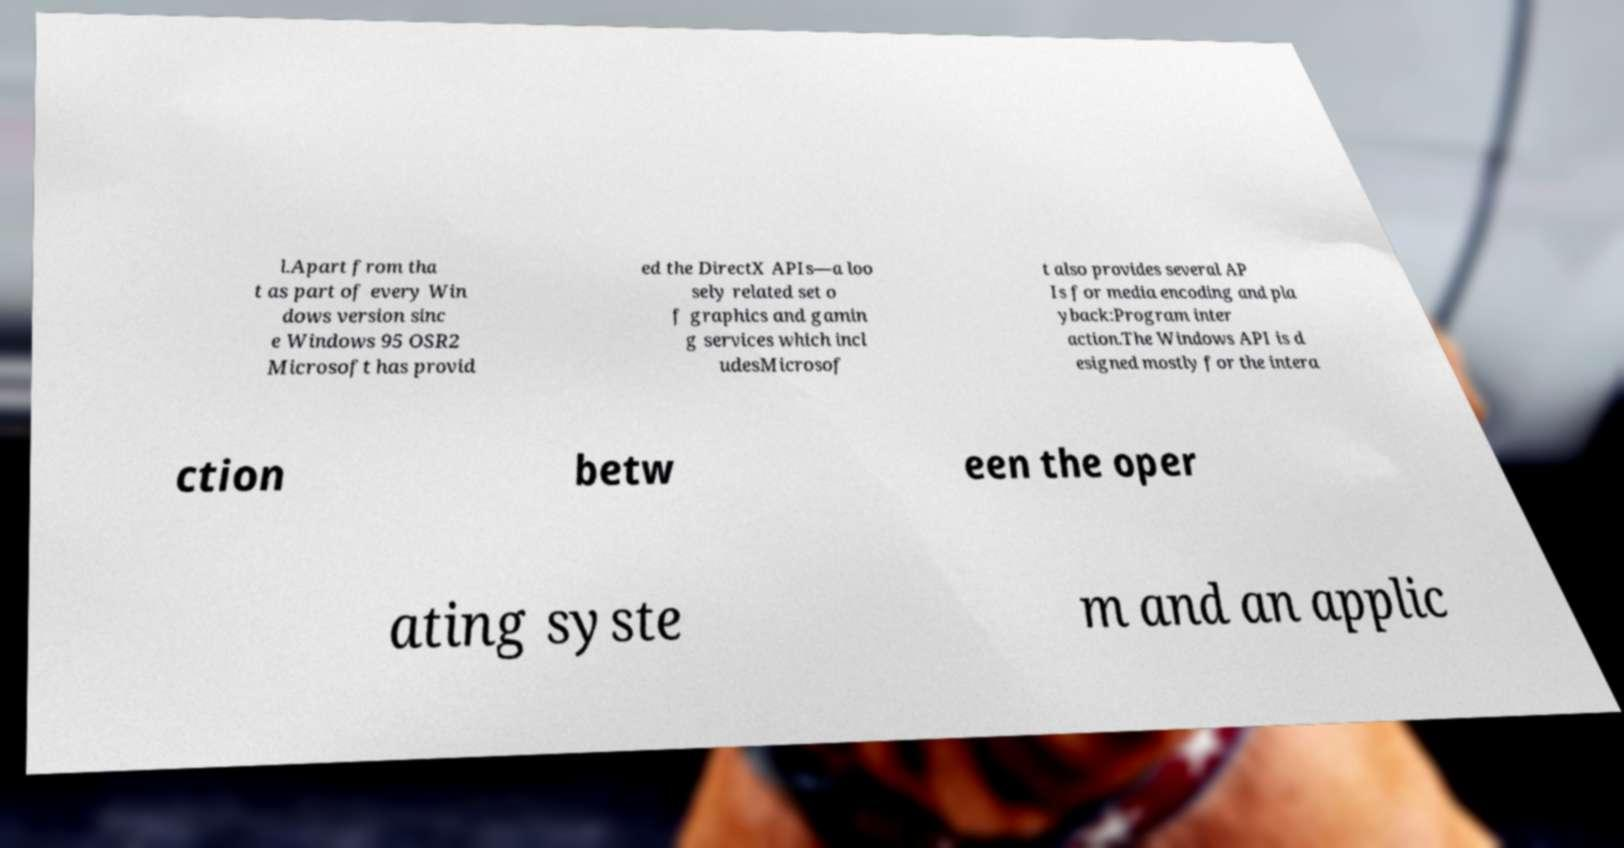Could you extract and type out the text from this image? l.Apart from tha t as part of every Win dows version sinc e Windows 95 OSR2 Microsoft has provid ed the DirectX APIs—a loo sely related set o f graphics and gamin g services which incl udesMicrosof t also provides several AP Is for media encoding and pla yback:Program inter action.The Windows API is d esigned mostly for the intera ction betw een the oper ating syste m and an applic 